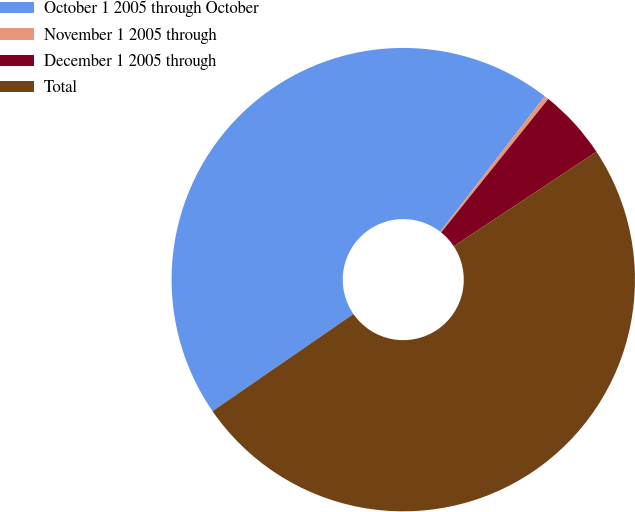<chart> <loc_0><loc_0><loc_500><loc_500><pie_chart><fcel>October 1 2005 through October<fcel>November 1 2005 through<fcel>December 1 2005 through<fcel>Total<nl><fcel>45.07%<fcel>0.3%<fcel>4.93%<fcel>49.7%<nl></chart> 